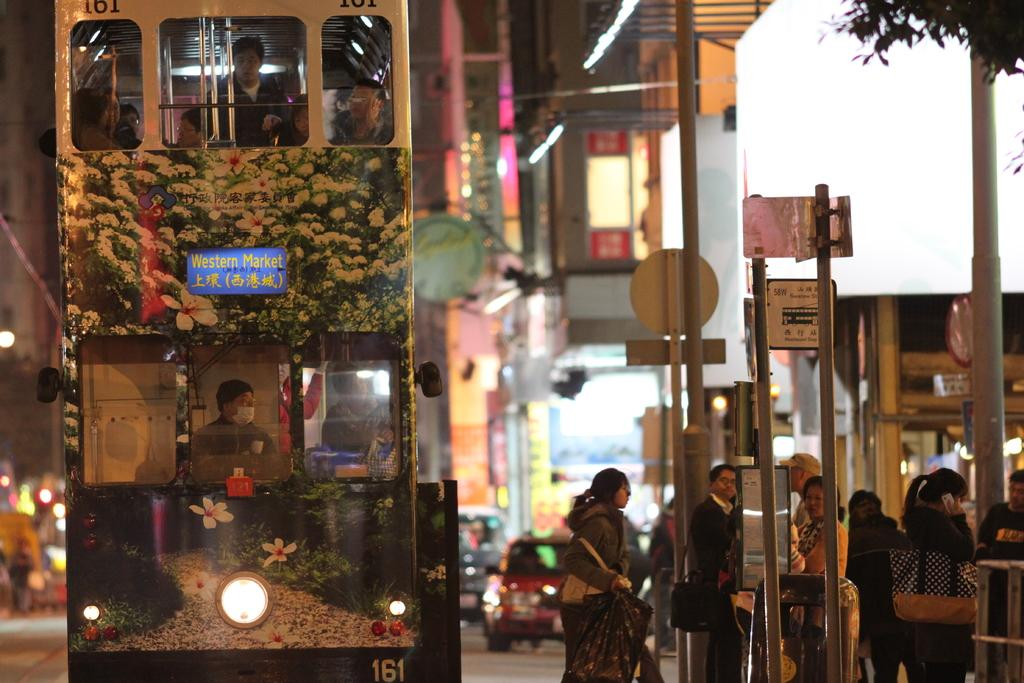What can be seen on the right side of the image? There are people standing on the footpath near a signal on the right side of the image. What is located on the left side of the image? There is a double-decker bus on the left side of the image. What else is present on the left side of the image besides the bus? There are other vehicles on the road on the left side of the image. Where is the sink located in the image? There is no sink present in the image. Can you see any wounds on the people standing on the footpath? There is no indication of any wounds on the people in the image. 